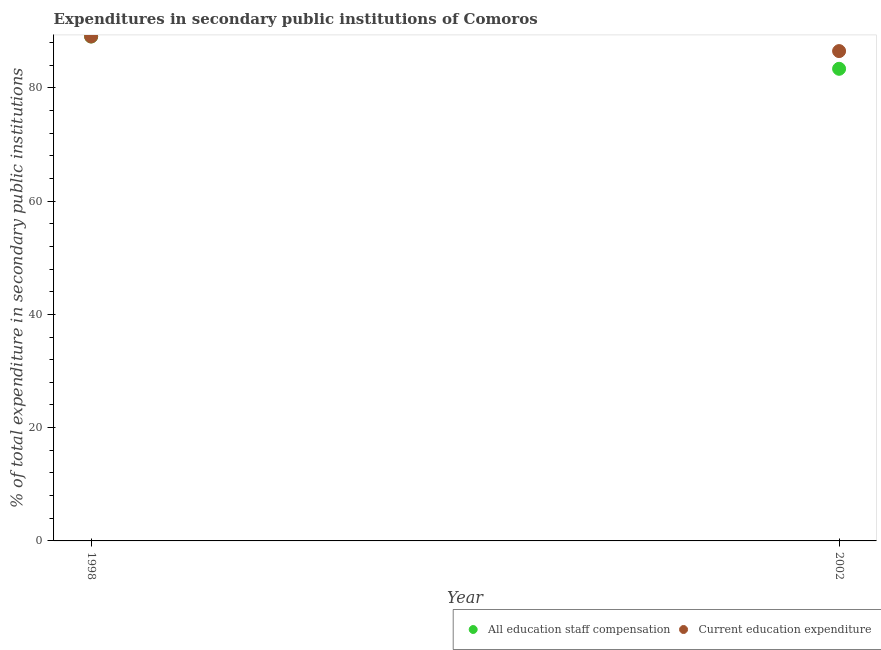Is the number of dotlines equal to the number of legend labels?
Provide a succinct answer. Yes. What is the expenditure in education in 1998?
Offer a very short reply. 89.06. Across all years, what is the maximum expenditure in education?
Your response must be concise. 89.06. Across all years, what is the minimum expenditure in education?
Your answer should be compact. 86.48. In which year was the expenditure in education maximum?
Your answer should be very brief. 1998. In which year was the expenditure in staff compensation minimum?
Give a very brief answer. 2002. What is the total expenditure in staff compensation in the graph?
Keep it short and to the point. 172.42. What is the difference between the expenditure in staff compensation in 1998 and that in 2002?
Offer a very short reply. 5.7. What is the difference between the expenditure in education in 2002 and the expenditure in staff compensation in 1998?
Provide a succinct answer. -2.58. What is the average expenditure in staff compensation per year?
Your answer should be very brief. 86.21. In how many years, is the expenditure in education greater than 36 %?
Your answer should be compact. 2. What is the ratio of the expenditure in staff compensation in 1998 to that in 2002?
Your answer should be compact. 1.07. Is the expenditure in education in 1998 less than that in 2002?
Make the answer very short. No. Does the graph contain any zero values?
Your answer should be very brief. No. Where does the legend appear in the graph?
Make the answer very short. Bottom right. What is the title of the graph?
Give a very brief answer. Expenditures in secondary public institutions of Comoros. Does "National Visitors" appear as one of the legend labels in the graph?
Keep it short and to the point. No. What is the label or title of the X-axis?
Give a very brief answer. Year. What is the label or title of the Y-axis?
Offer a very short reply. % of total expenditure in secondary public institutions. What is the % of total expenditure in secondary public institutions in All education staff compensation in 1998?
Keep it short and to the point. 89.06. What is the % of total expenditure in secondary public institutions of Current education expenditure in 1998?
Offer a very short reply. 89.06. What is the % of total expenditure in secondary public institutions of All education staff compensation in 2002?
Provide a short and direct response. 83.36. What is the % of total expenditure in secondary public institutions of Current education expenditure in 2002?
Provide a short and direct response. 86.48. Across all years, what is the maximum % of total expenditure in secondary public institutions of All education staff compensation?
Your response must be concise. 89.06. Across all years, what is the maximum % of total expenditure in secondary public institutions of Current education expenditure?
Your answer should be very brief. 89.06. Across all years, what is the minimum % of total expenditure in secondary public institutions of All education staff compensation?
Your answer should be compact. 83.36. Across all years, what is the minimum % of total expenditure in secondary public institutions in Current education expenditure?
Your answer should be very brief. 86.48. What is the total % of total expenditure in secondary public institutions of All education staff compensation in the graph?
Provide a short and direct response. 172.42. What is the total % of total expenditure in secondary public institutions in Current education expenditure in the graph?
Give a very brief answer. 175.54. What is the difference between the % of total expenditure in secondary public institutions of All education staff compensation in 1998 and that in 2002?
Ensure brevity in your answer.  5.7. What is the difference between the % of total expenditure in secondary public institutions of Current education expenditure in 1998 and that in 2002?
Provide a short and direct response. 2.58. What is the difference between the % of total expenditure in secondary public institutions of All education staff compensation in 1998 and the % of total expenditure in secondary public institutions of Current education expenditure in 2002?
Your response must be concise. 2.58. What is the average % of total expenditure in secondary public institutions of All education staff compensation per year?
Provide a short and direct response. 86.21. What is the average % of total expenditure in secondary public institutions of Current education expenditure per year?
Offer a terse response. 87.77. In the year 1998, what is the difference between the % of total expenditure in secondary public institutions of All education staff compensation and % of total expenditure in secondary public institutions of Current education expenditure?
Provide a short and direct response. 0. In the year 2002, what is the difference between the % of total expenditure in secondary public institutions of All education staff compensation and % of total expenditure in secondary public institutions of Current education expenditure?
Your response must be concise. -3.13. What is the ratio of the % of total expenditure in secondary public institutions of All education staff compensation in 1998 to that in 2002?
Give a very brief answer. 1.07. What is the ratio of the % of total expenditure in secondary public institutions in Current education expenditure in 1998 to that in 2002?
Your answer should be compact. 1.03. What is the difference between the highest and the second highest % of total expenditure in secondary public institutions of All education staff compensation?
Offer a very short reply. 5.7. What is the difference between the highest and the second highest % of total expenditure in secondary public institutions in Current education expenditure?
Provide a succinct answer. 2.58. What is the difference between the highest and the lowest % of total expenditure in secondary public institutions in All education staff compensation?
Keep it short and to the point. 5.7. What is the difference between the highest and the lowest % of total expenditure in secondary public institutions in Current education expenditure?
Offer a very short reply. 2.58. 